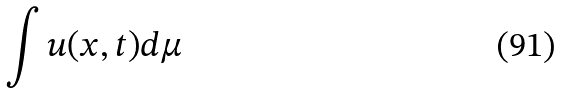Convert formula to latex. <formula><loc_0><loc_0><loc_500><loc_500>\int u ( x , t ) d \mu</formula> 